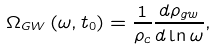Convert formula to latex. <formula><loc_0><loc_0><loc_500><loc_500>\Omega _ { G W } \left ( \omega , t _ { 0 } \right ) = \frac { 1 } { \rho _ { c } } \frac { d \rho _ { g w } } { d \ln \omega } ,</formula> 